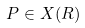Convert formula to latex. <formula><loc_0><loc_0><loc_500><loc_500>P \in X ( R )</formula> 